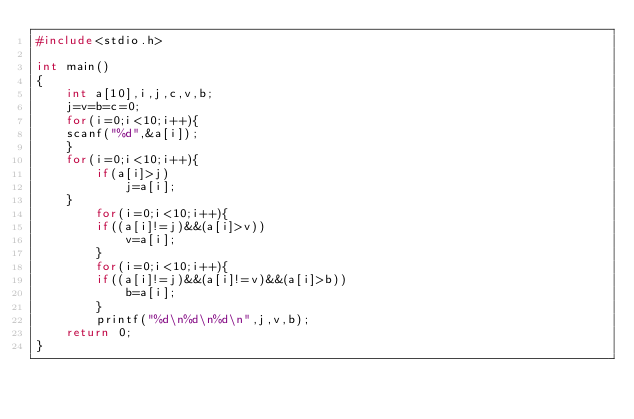<code> <loc_0><loc_0><loc_500><loc_500><_C_>#include<stdio.h>

int main()
{
	int a[10],i,j,c,v,b;
	j=v=b=c=0;
	for(i=0;i<10;i++){
	scanf("%d",&a[i]);
	}
    for(i=0;i<10;i++){
		if(a[i]>j)
			j=a[i];
	}
		for(i=0;i<10;i++){
		if((a[i]!=j)&&(a[i]>v))
			v=a[i];
		}
		for(i=0;i<10;i++){
		if((a[i]!=j)&&(a[i]!=v)&&(a[i]>b))
			b=a[i];
		}
		printf("%d\n%d\n%d\n",j,v,b);
	return 0;
}</code> 